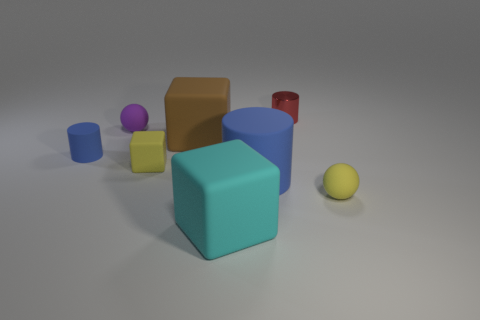Subtract all small yellow cubes. How many cubes are left? 2 Add 1 blue things. How many objects exist? 9 Subtract all red cylinders. How many cylinders are left? 2 Subtract all cubes. How many objects are left? 5 Subtract 3 cylinders. How many cylinders are left? 0 Subtract all gray cubes. Subtract all cyan cylinders. How many cubes are left? 3 Subtract all blue cylinders. How many yellow blocks are left? 1 Subtract all big blue rubber cylinders. Subtract all yellow rubber spheres. How many objects are left? 6 Add 6 small spheres. How many small spheres are left? 8 Add 3 small metal objects. How many small metal objects exist? 4 